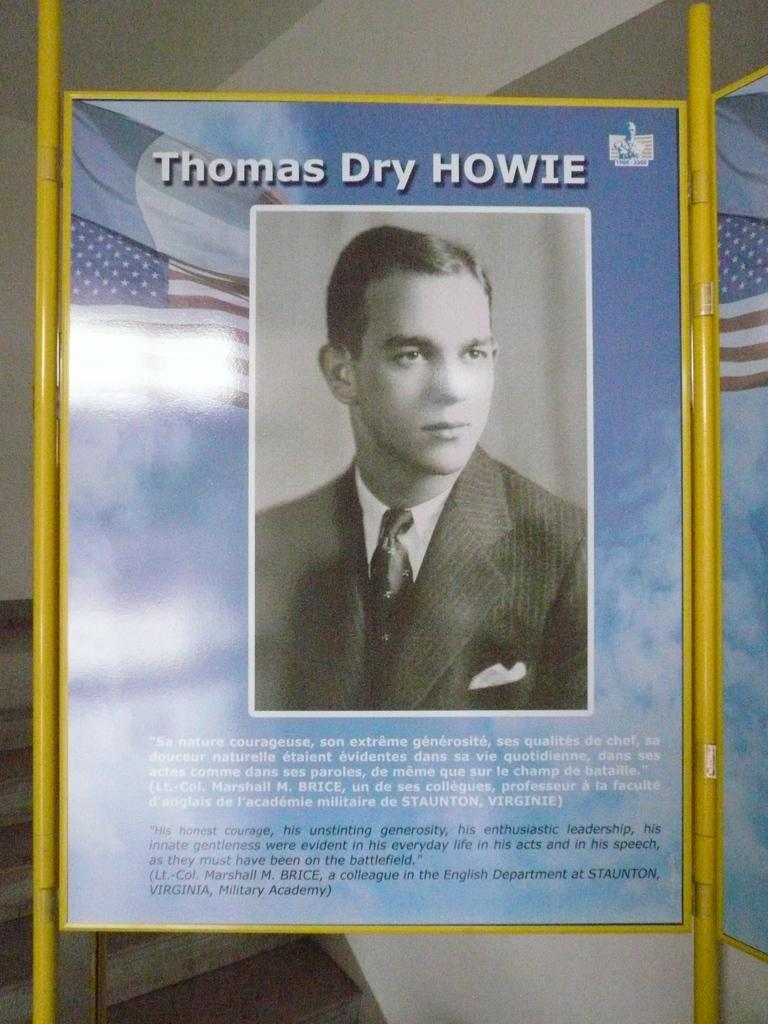<image>
Render a clear and concise summary of the photo. The poster displayed with the black and white picture is of Thomas Dry Howie. 